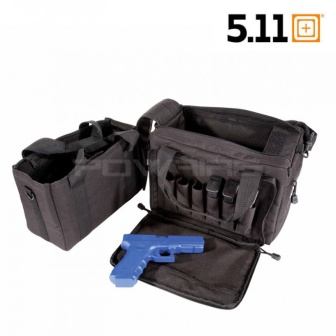What purpose might this tactical bag serve in a professional setting? Given its robust design and multiple compartments, this tactical bag could be used by law enforcement or military personnel to carry essential gear, such as communication devices, first aid kits, and specialized tools. The compartments allow for organized storage, enabling quick access in critical situations, which is paramount in professional settings where time and efficiency are crucial. 